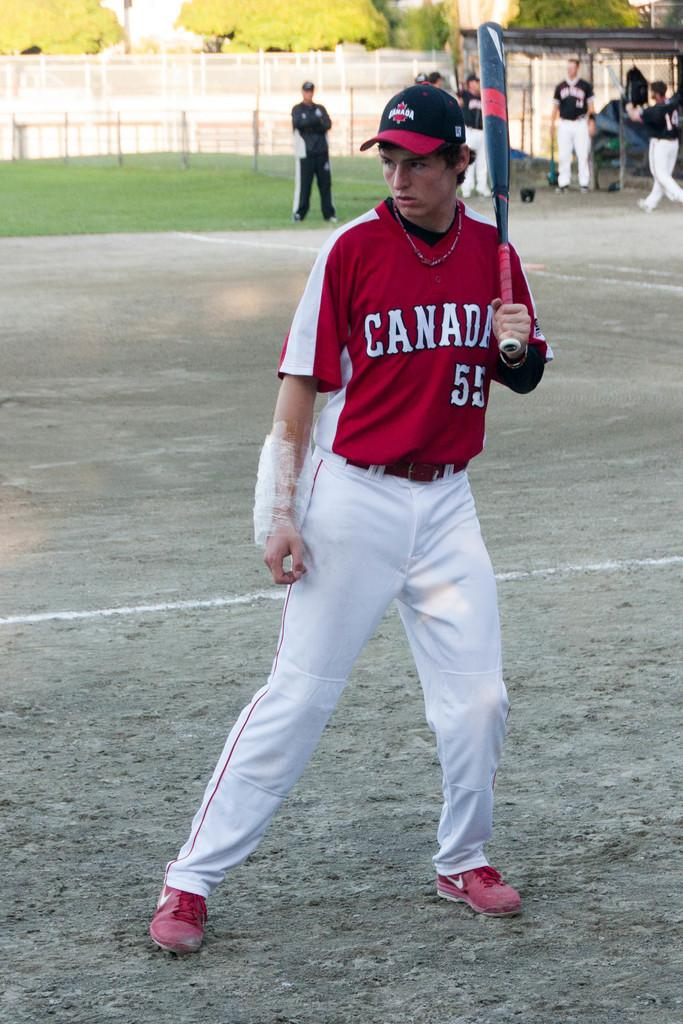Provide a one-sentence caption for the provided image. a baseball player wearing a jersey saying canada. 